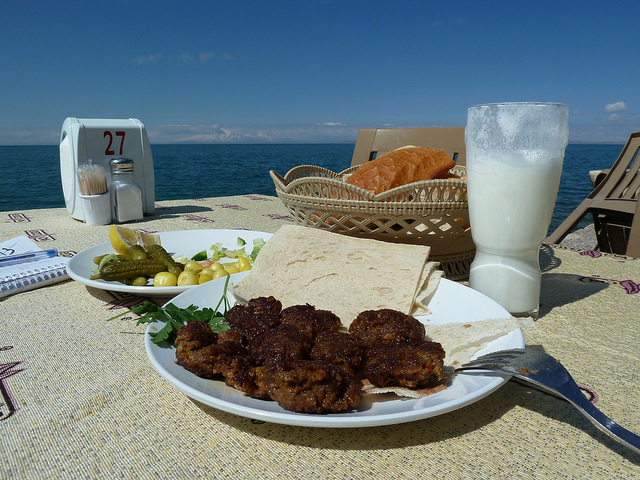Identify the text contained in this image. 27 13 